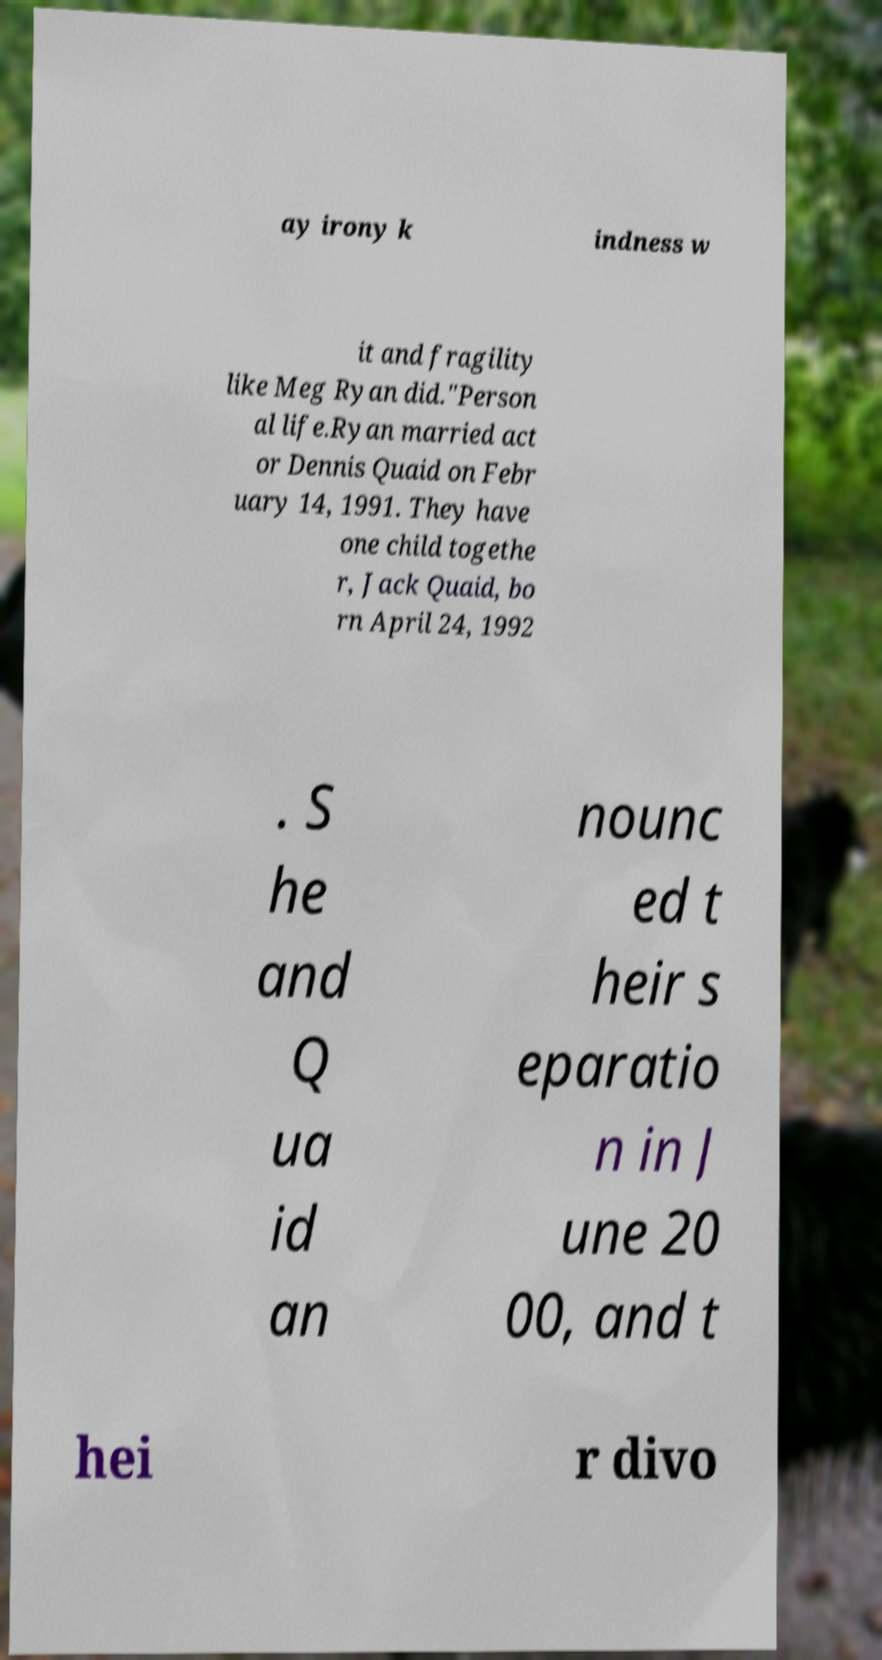Could you extract and type out the text from this image? ay irony k indness w it and fragility like Meg Ryan did."Person al life.Ryan married act or Dennis Quaid on Febr uary 14, 1991. They have one child togethe r, Jack Quaid, bo rn April 24, 1992 . S he and Q ua id an nounc ed t heir s eparatio n in J une 20 00, and t hei r divo 